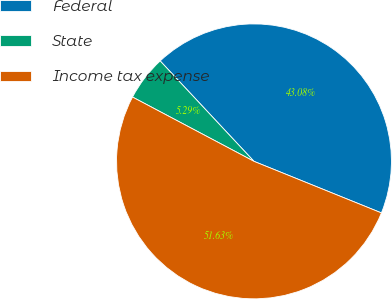<chart> <loc_0><loc_0><loc_500><loc_500><pie_chart><fcel>Federal<fcel>State<fcel>Income tax expense<nl><fcel>43.08%<fcel>5.29%<fcel>51.63%<nl></chart> 